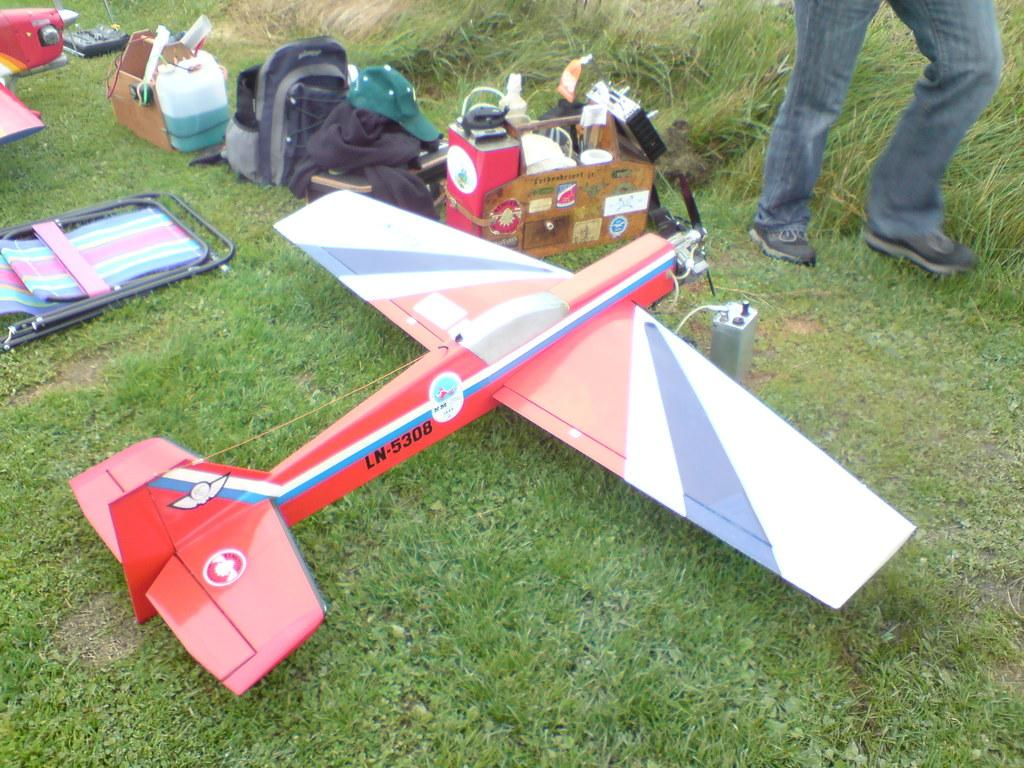Provide a one-sentence caption for the provided image. A red colored remote plane  which named as LN-5308 is  placed in a land. 